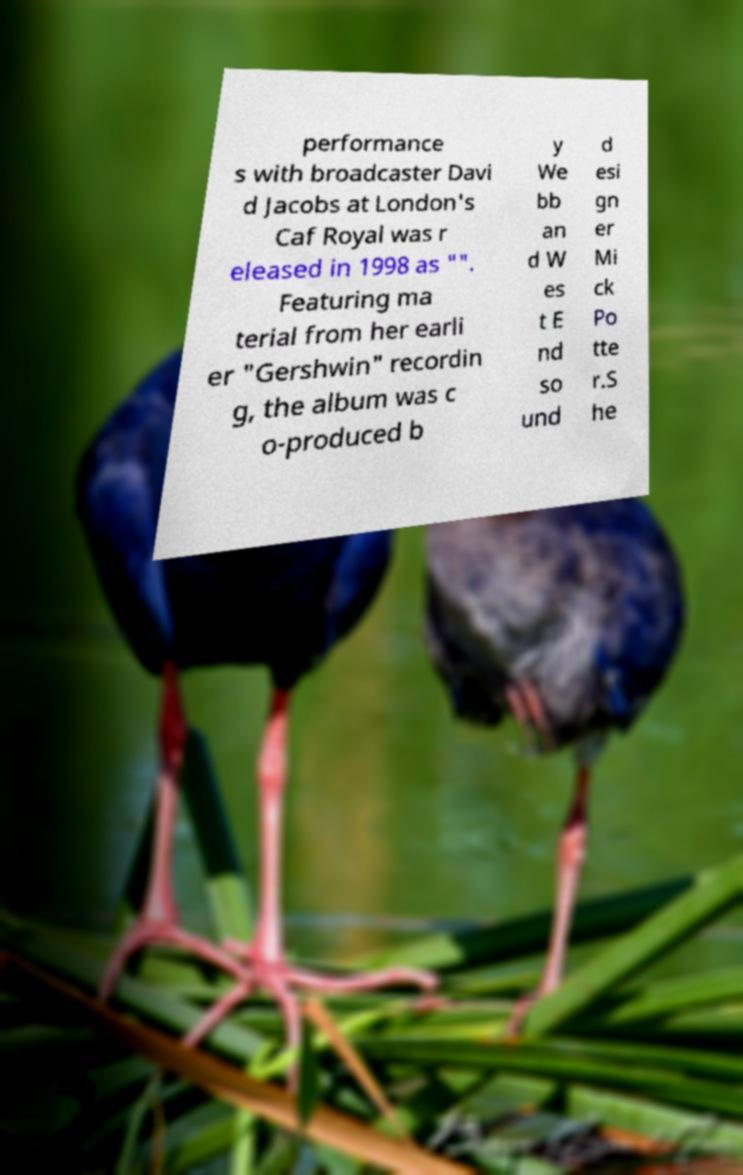Please read and relay the text visible in this image. What does it say? performance s with broadcaster Davi d Jacobs at London's Caf Royal was r eleased in 1998 as "". Featuring ma terial from her earli er "Gershwin" recordin g, the album was c o-produced b y We bb an d W es t E nd so und d esi gn er Mi ck Po tte r.S he 